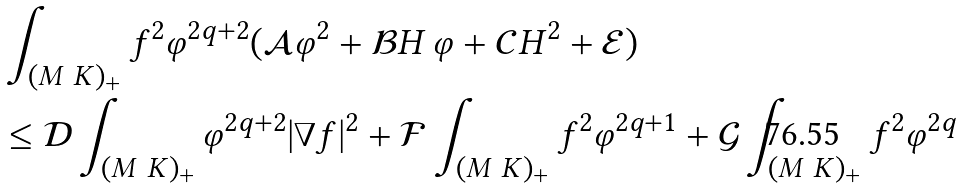Convert formula to latex. <formula><loc_0><loc_0><loc_500><loc_500>& \int _ { ( M \ K ) _ { + } } f ^ { 2 } \varphi ^ { 2 q + 2 } ( { \mathcal { A } } \varphi ^ { 2 } + { \mathcal { B } } H \, \varphi + { \mathcal { C } } H ^ { 2 } + { \mathcal { E } } ) \\ & \leq { \mathcal { D } } \int _ { ( M \ K ) _ { + } } \varphi ^ { 2 q + 2 } | \nabla f | ^ { 2 } + { \mathcal { F } } \int _ { ( M \ K ) _ { + } } f ^ { 2 } \varphi ^ { 2 q + 1 } + { \mathcal { G } } \int _ { ( M \ K ) _ { + } } f ^ { 2 } \varphi ^ { 2 q }</formula> 